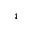<formula> <loc_0><loc_0><loc_500><loc_500>^ { 4 }</formula> 